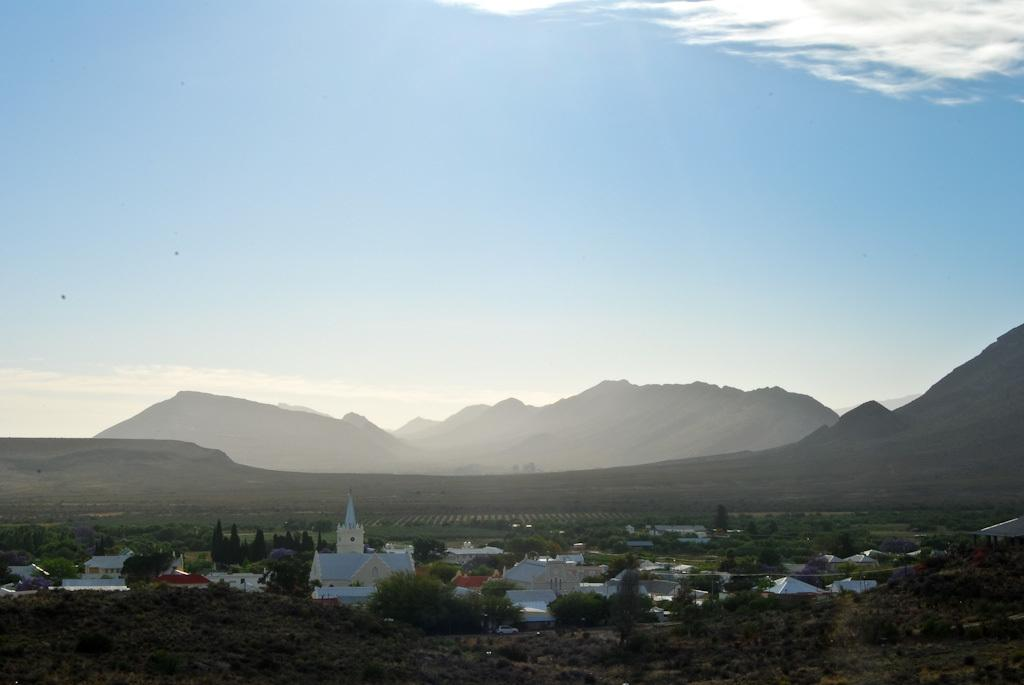What can be seen at the top of the image? The sky is visible in the image. What type of landscape feature is present in the image? There are hills in the image. What structures are located at the bottom of the image? There are houses at the bottom of the image. What type of vegetation is present at the bottom of the image? Trees are present at the bottom of the image. What is visible at the bottom of the image, besides the houses and trees? The ground is visible at the bottom of the image. Can you tell me how many cans are visible in the image? There are no cans present in the image. What type of vein is visible in the image? There are no veins visible in the image; it is a landscape scene. 